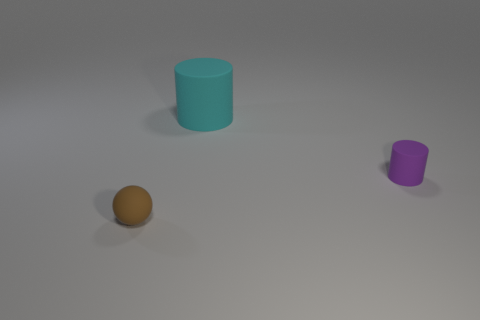What number of matte things are on the right side of the tiny brown ball and in front of the large cyan thing?
Provide a short and direct response. 1. Is the material of the small purple cylinder the same as the cylinder that is behind the purple cylinder?
Keep it short and to the point. Yes. How many brown things are matte things or balls?
Offer a terse response. 1. Is there a red shiny cylinder that has the same size as the brown object?
Your response must be concise. No. There is a thing that is on the right side of the object behind the cylinder to the right of the big rubber cylinder; what is its material?
Your answer should be compact. Rubber. Are there the same number of purple cylinders that are right of the purple object and small red matte objects?
Offer a very short reply. Yes. Are the small thing to the right of the small brown matte ball and the tiny object that is in front of the small rubber cylinder made of the same material?
Your response must be concise. Yes. What number of things are either large red spheres or objects to the right of the brown object?
Make the answer very short. 2. Is there a purple rubber thing of the same shape as the big cyan rubber thing?
Give a very brief answer. Yes. What size is the cylinder that is behind the thing that is on the right side of the thing behind the tiny purple cylinder?
Give a very brief answer. Large. 